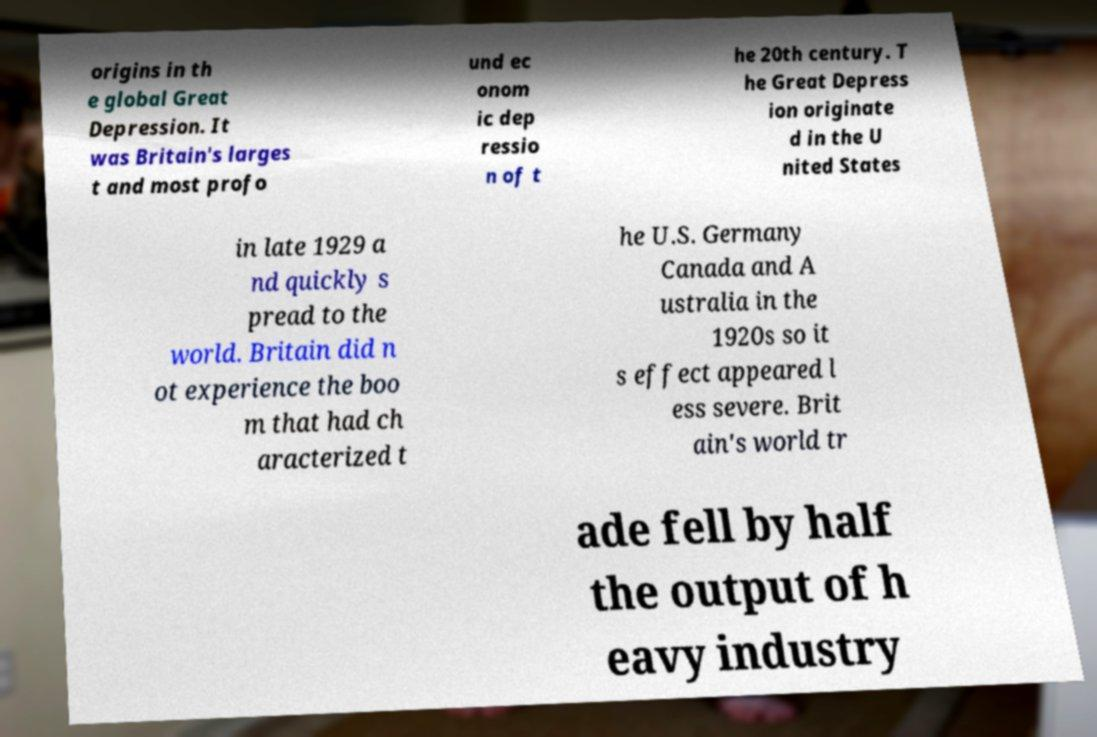Could you assist in decoding the text presented in this image and type it out clearly? origins in th e global Great Depression. It was Britain's larges t and most profo und ec onom ic dep ressio n of t he 20th century. T he Great Depress ion originate d in the U nited States in late 1929 a nd quickly s pread to the world. Britain did n ot experience the boo m that had ch aracterized t he U.S. Germany Canada and A ustralia in the 1920s so it s effect appeared l ess severe. Brit ain's world tr ade fell by half the output of h eavy industry 